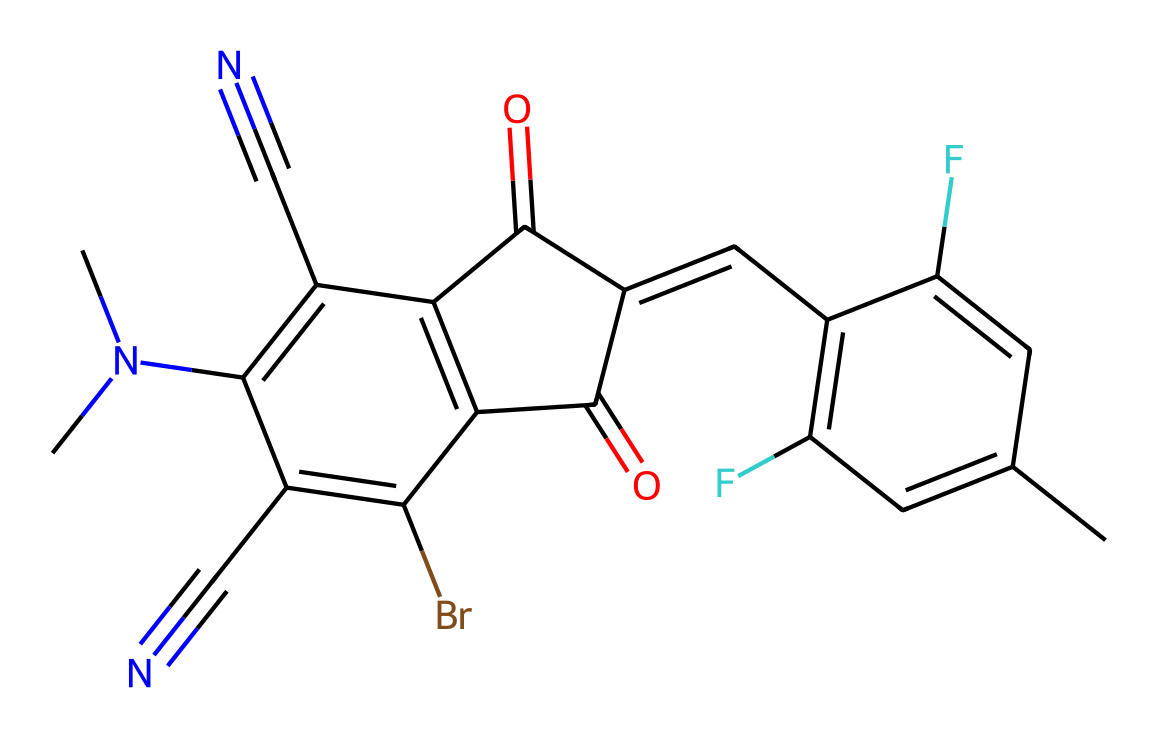What is the molecular formula of this compound? To determine the molecular formula, count the total number of each type of atom in the SMILES representation: Carbon (C), Hydrogen (H), Fluorine (F), Bromine (Br), Nitrogen (N), and Oxygen (O). This yields: C14H12F2BrN4O2.
Answer: C14H12F2BrN4O2 How many halogen atoms are present in the compound? The compound contains two types of halogen atoms: Fluorine (F) and Bromine (Br). By counting, there are 2 Fluorine atoms and 1 Bromine atom, yielding a total of 3 halogen atoms.
Answer: 3 What class of organic molecules does this compound belong to? By analyzing the structure, particularly the presence of aromatic rings (such as the benzene-like structure) and the multiple functional groups, one can classify this compound as a halogen-containing organic semiconductor.
Answer: halogen-containing organic semiconductor What is the role of fluorine in this compound’s properties? Fluorine's presence typically enhances the solubility and stability of organic semiconductors due to its electronegativity and ability to participate in strong intermolecular interactions (like hydrogen bonding in the presence of suitable donors).
Answer: enhances solubility and stability Which atom in the chemical is likely to influence the electronic properties significantly? The presence of nitrogen atoms, especially in the context of forming imine or nitrile groups, can significantly influence the electronic properties by introducing electron-withdrawing characteristics.
Answer: nitrogen How many conjugated double bonds can be identified in the structure? A systematic analysis of the structure reveals a number of double bonds between carbon atoms within cyclic and acyclic portions of the molecule. Specifically, there are three double bonds (C=C).
Answer: 3 What type of chemical reaction can this compound potentially undergo? Considering the functional groups present, such as the bromine atom, this compound could potentially undergo nucleophilic substitution reactions, typical for alkyl halides.
Answer: nucleophilic substitution 